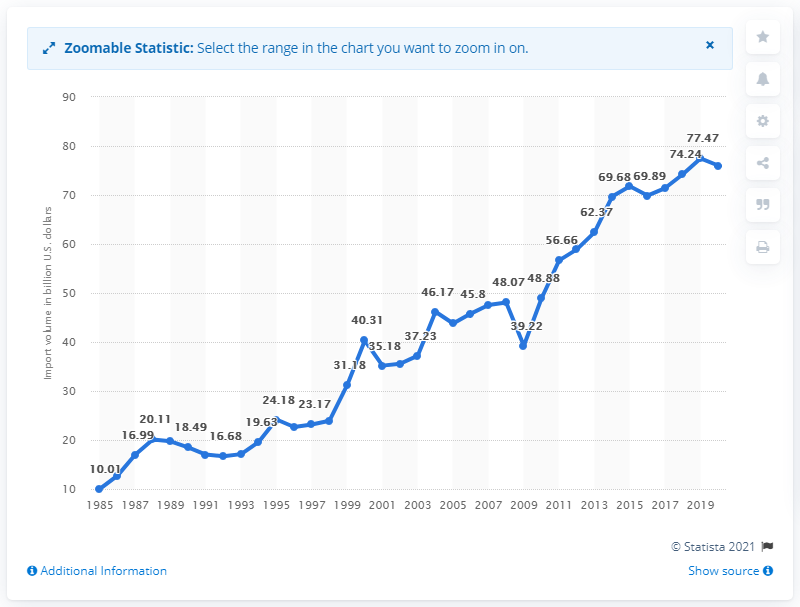Identify some key points in this picture. In 2020, the value of imports from South Korea was 76.02 dollars. 